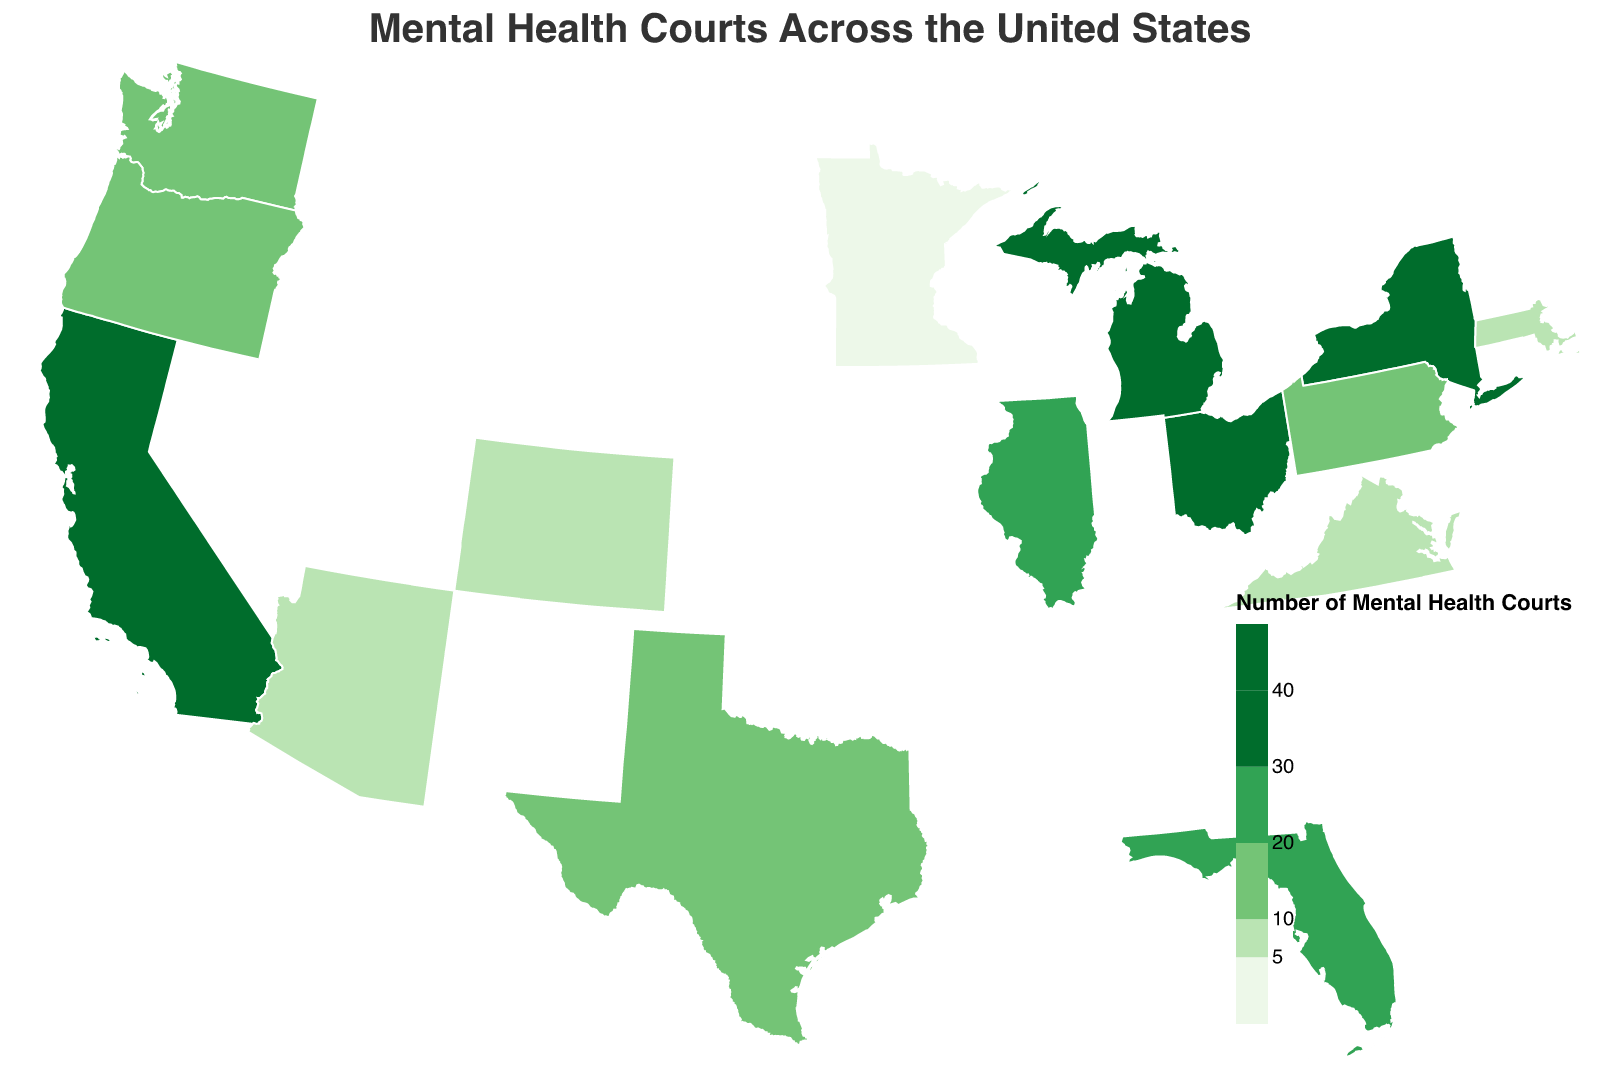What is the title of the figure? The title of the figure is usually prominently displayed at the top. It summarizes what the map is about.
Answer: Mental Health Courts Across the United States Which state has the highest number of mental health courts? Scan the map for the darkest color indication or refer to the tooltip for the numbers.
Answer: California When was the first mental health court implemented in Ohio? The tooltip provides this information when you hover over Ohio on the map.
Answer: 2001 Which states have a judge satisfaction score of 6? Look at the tooltip data for each state and note down the states with a satisfaction score of 6.
Answer: Pennsylvania, Colorado, Arizona What is the total number of mental health courts in Florida and Michigan combined? Sum up the number of mental health courts in Florida (27) and Michigan (33).
Answer: 60 Is the number of mental health courts in Texas greater than in New York? Compare the numbers shown in the tooltip when hovering over Texas (18) and New York (30).
Answer: No Which state has the lowest judge satisfaction score and how many mental health courts does it have? Find the lowest judge satisfaction score in the tooltip, then refer to the number of mental health courts for that state.
Answer: Virginia, 5 What is the average implementation year of the mental health courts in Massachusetts, Virginia, Oregon, and Arizona? Average the implementation years: (2006 (MA) + 2010 (VA) + 2007 (OR) + 2011 (AZ)) / 4.
Answer: 2008.5 What is the median number of mental health courts across all states? Order the number of mental health courts and find the middle value. The ordered list is 3, 5, 6, 7, 8, 11, 12, 17, 18, 24, 27, 30, 33, 38, 45. The median is the 8th value in a list of 15.
Answer: 17 Which state had its first mental health court most recently and how many courts does it have? Look for the latest year in the tooltip data to find the most recent implementation, then note the number of courts in that state.
Answer: Minnesota, 3 